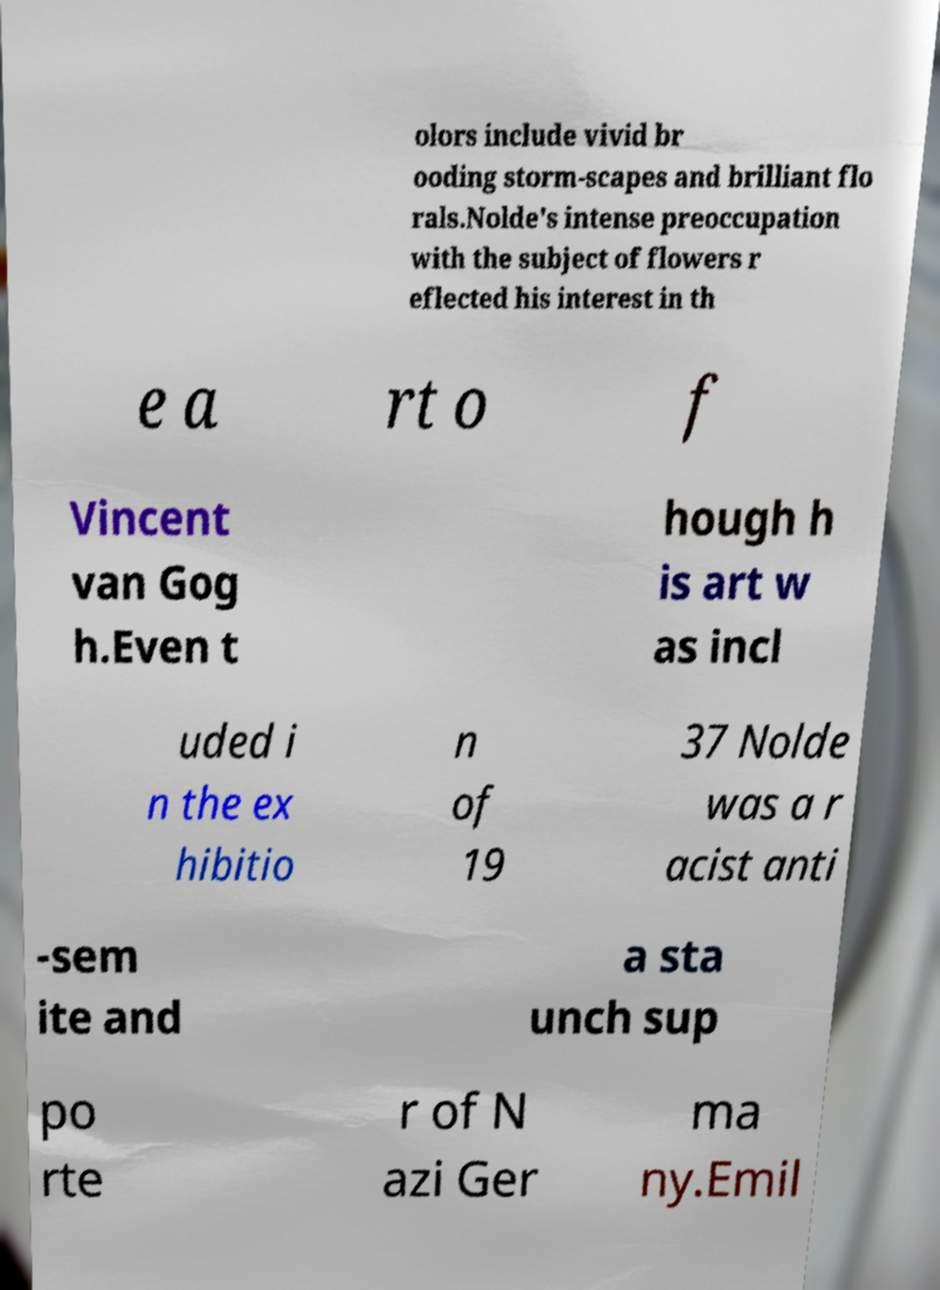Could you extract and type out the text from this image? olors include vivid br ooding storm-scapes and brilliant flo rals.Nolde's intense preoccupation with the subject of flowers r eflected his interest in th e a rt o f Vincent van Gog h.Even t hough h is art w as incl uded i n the ex hibitio n of 19 37 Nolde was a r acist anti -sem ite and a sta unch sup po rte r of N azi Ger ma ny.Emil 